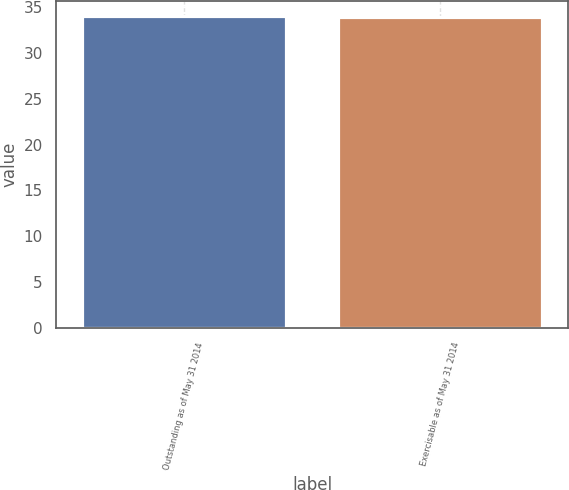Convert chart to OTSL. <chart><loc_0><loc_0><loc_500><loc_500><bar_chart><fcel>Outstanding as of May 31 2014<fcel>Exercisable as of May 31 2014<nl><fcel>34<fcel>33.87<nl></chart> 